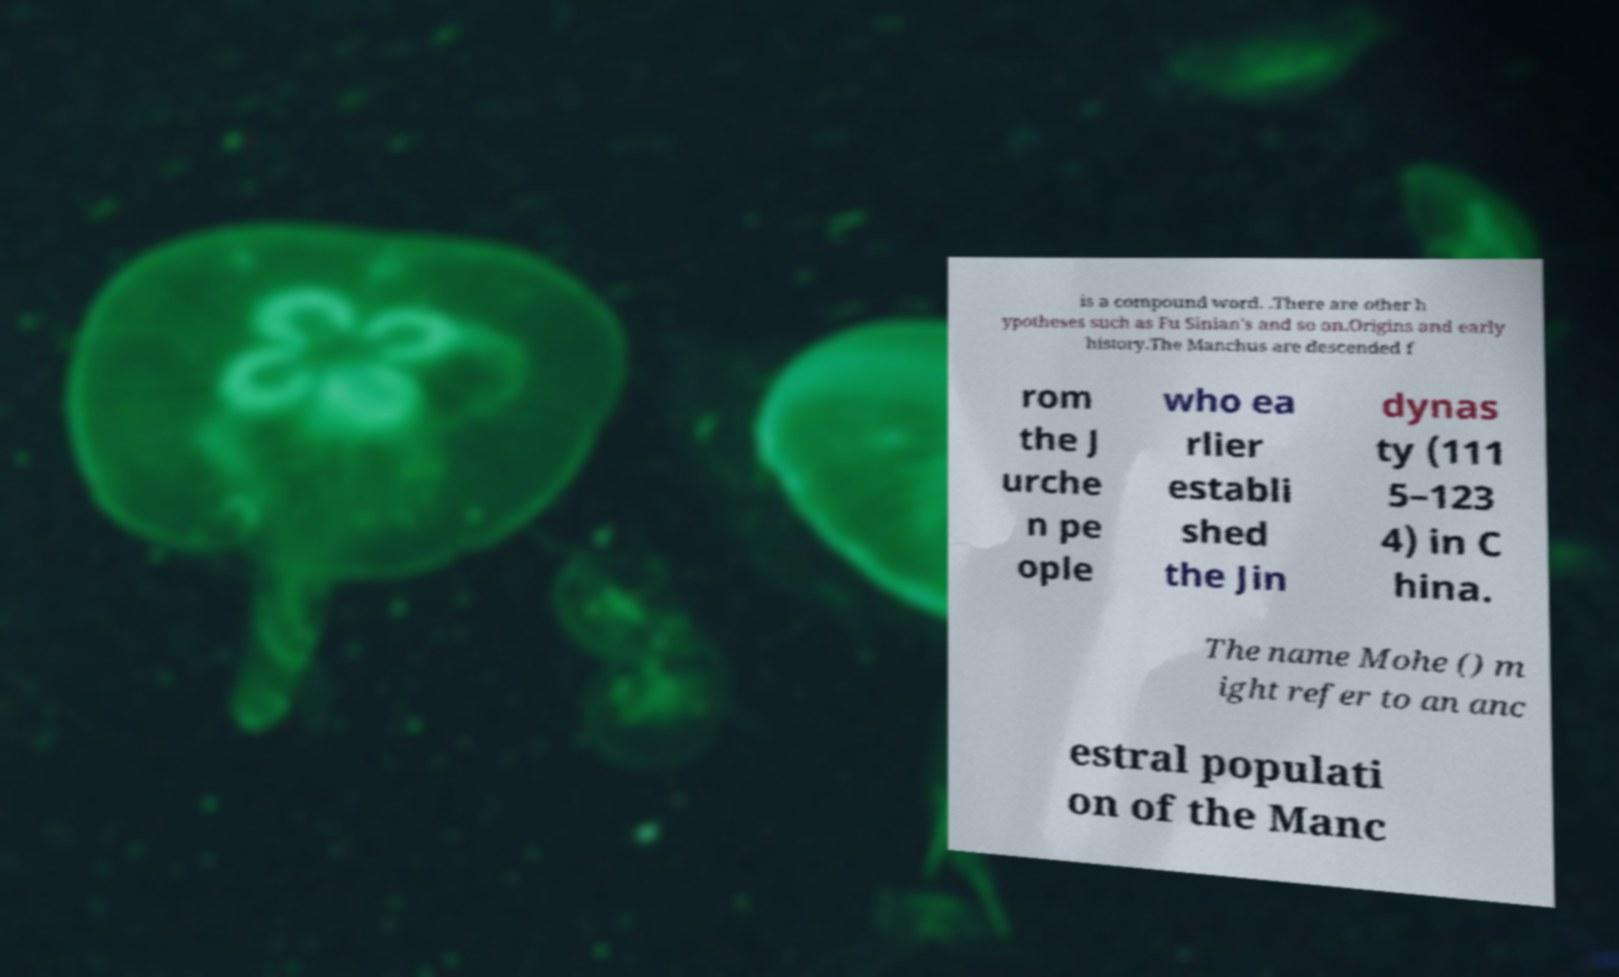Please read and relay the text visible in this image. What does it say? is a compound word. .There are other h ypotheses such as Fu Sinian's and so on.Origins and early history.The Manchus are descended f rom the J urche n pe ople who ea rlier establi shed the Jin dynas ty (111 5–123 4) in C hina. The name Mohe () m ight refer to an anc estral populati on of the Manc 